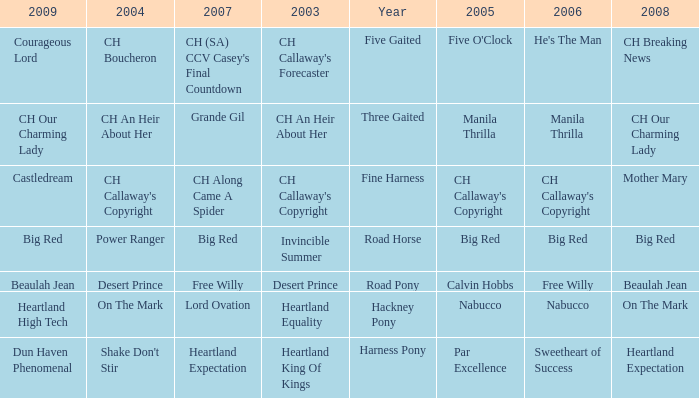What is the 2007 with ch callaway's copyright in 2003? CH Along Came A Spider. 